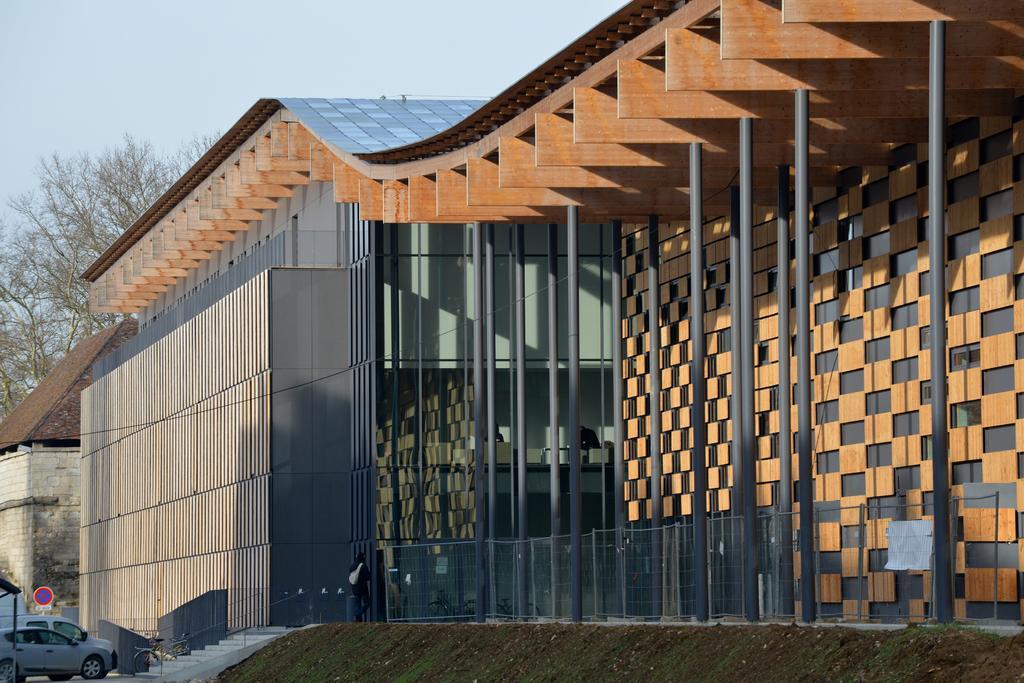Could you give a brief overview of what you see in this image? In this picture I can see there is a building, there are few cars parked at left side, there is a tree and the sky is clear. 